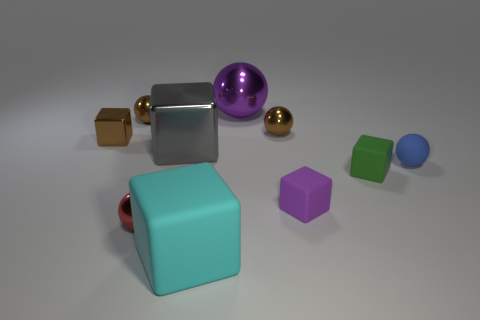There is a small matte thing that is to the left of the green block; what is its shape?
Offer a very short reply. Cube. There is a green object that is the same size as the blue ball; what shape is it?
Make the answer very short. Cube. The shiny sphere to the left of the metallic object that is in front of the big object that is left of the large cyan cube is what color?
Offer a very short reply. Brown. Do the cyan rubber thing and the small blue matte object have the same shape?
Ensure brevity in your answer.  No. Are there an equal number of big purple things that are in front of the large metal sphere and large cyan rubber cylinders?
Your response must be concise. Yes. How many other objects are there of the same material as the small green cube?
Provide a succinct answer. 3. There is a rubber thing behind the green rubber cube; is it the same size as the purple shiny thing behind the tiny shiny cube?
Ensure brevity in your answer.  No. What number of things are tiny brown things that are behind the brown metallic block or big metal things behind the blue matte sphere?
Keep it short and to the point. 4. Is there any other thing that has the same shape as the small green thing?
Ensure brevity in your answer.  Yes. Do the small cube that is left of the big cyan block and the big cube behind the small blue matte object have the same color?
Keep it short and to the point. No. 